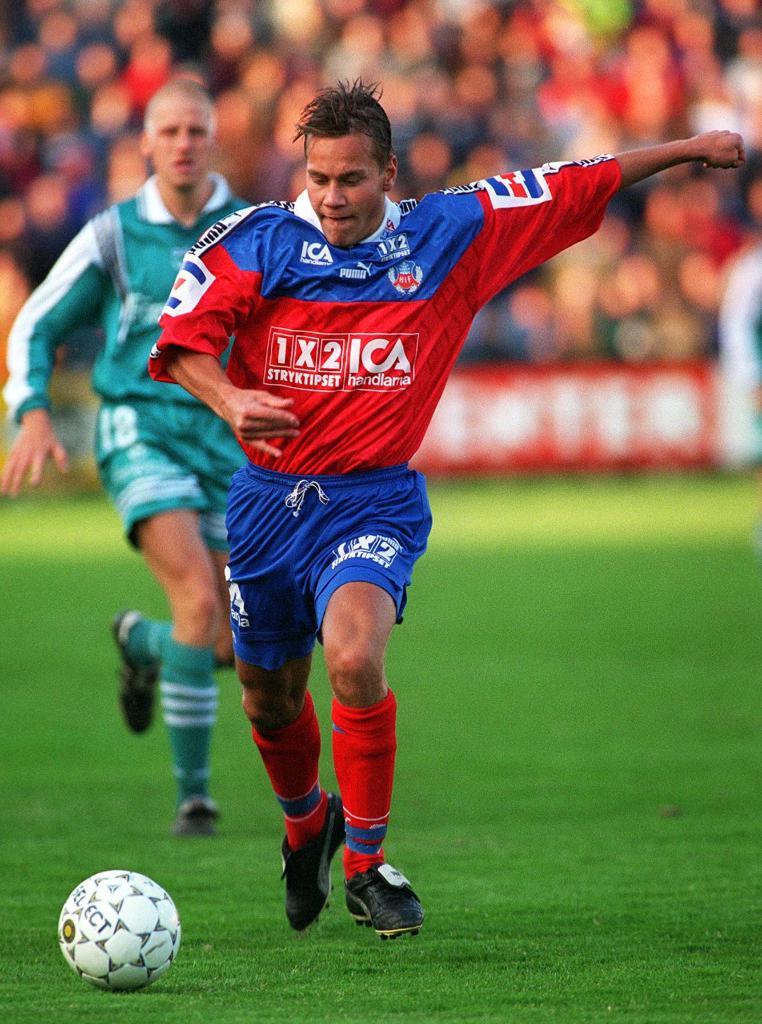What number is the green player?
Your answer should be very brief. 18. 